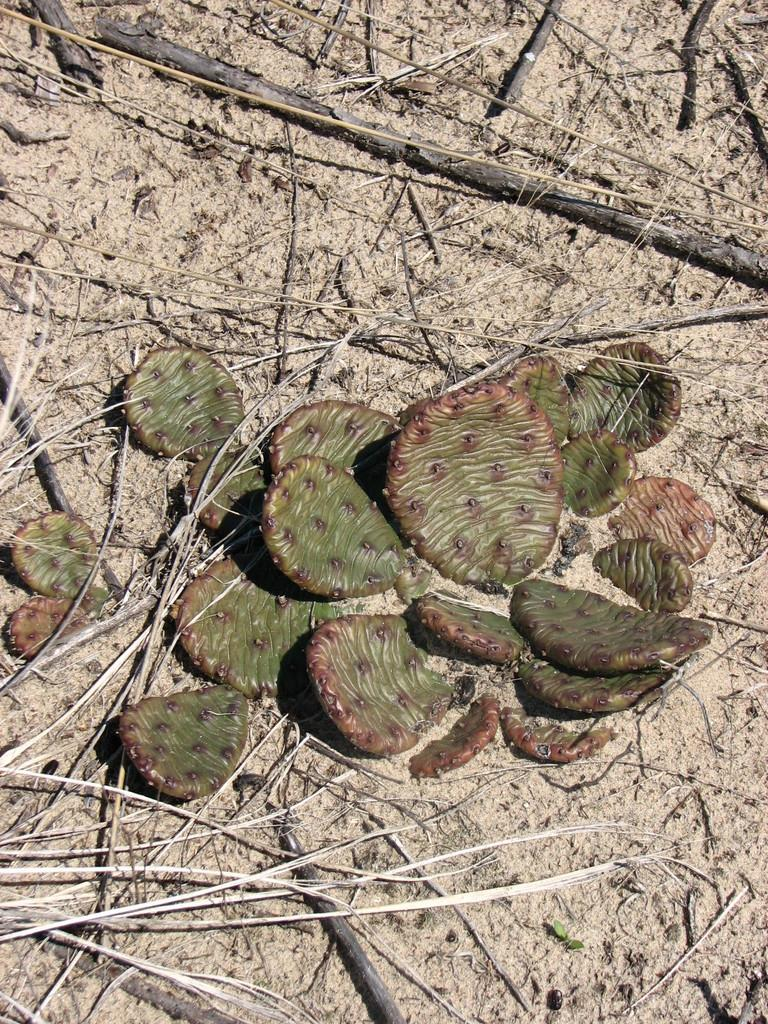What type of plant material is on the ground in the image? There are pieces of a dry cactus on the ground. Where is the faucet located in the image? There is no faucet present in the image; it only shows pieces of a dry cactus on the ground. 